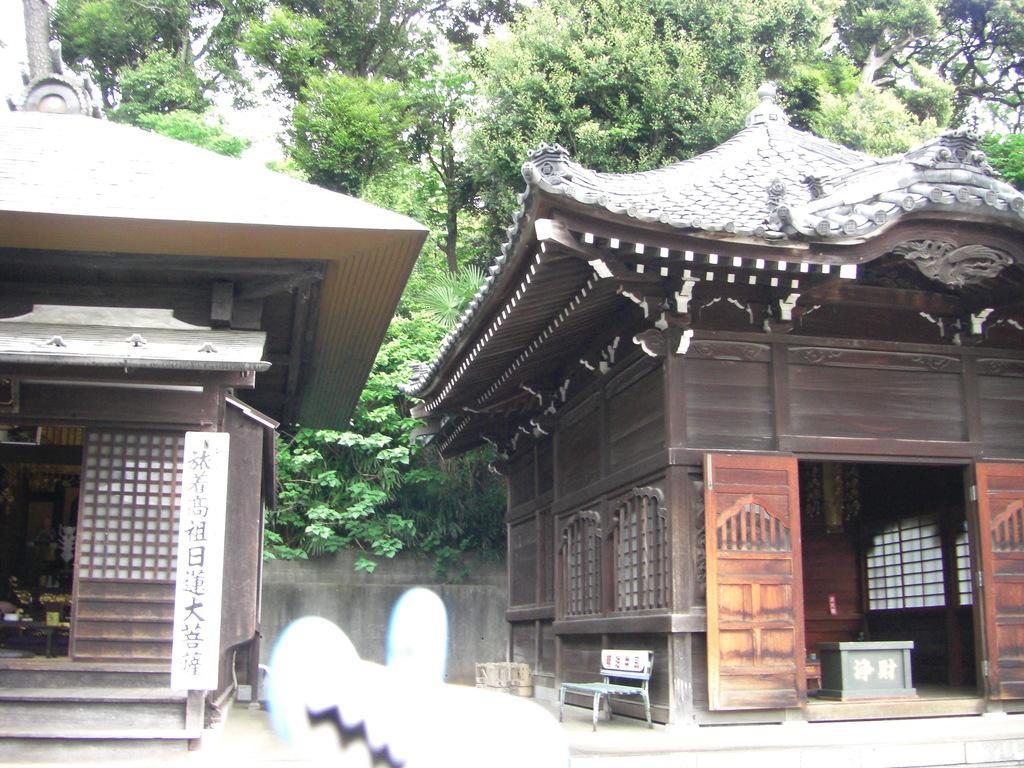In one or two sentences, can you explain what this image depicts? In the center of the image there are two houses. In the background of the image there are trees. 